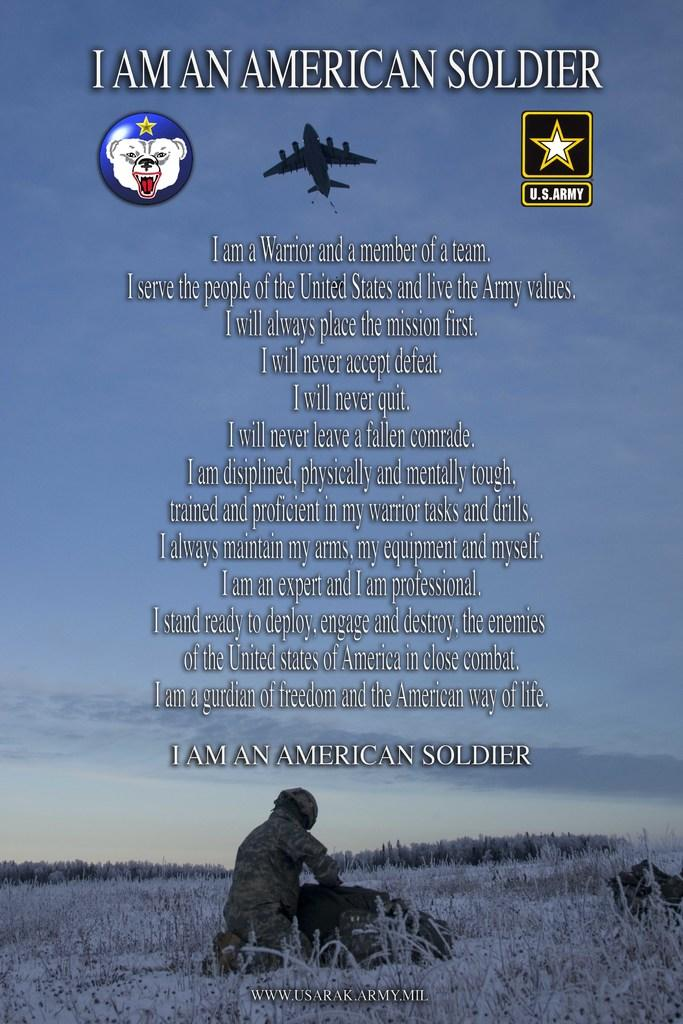<image>
Describe the image concisely. piece of propaganda for the united states army with the title of i am an american soldier. 